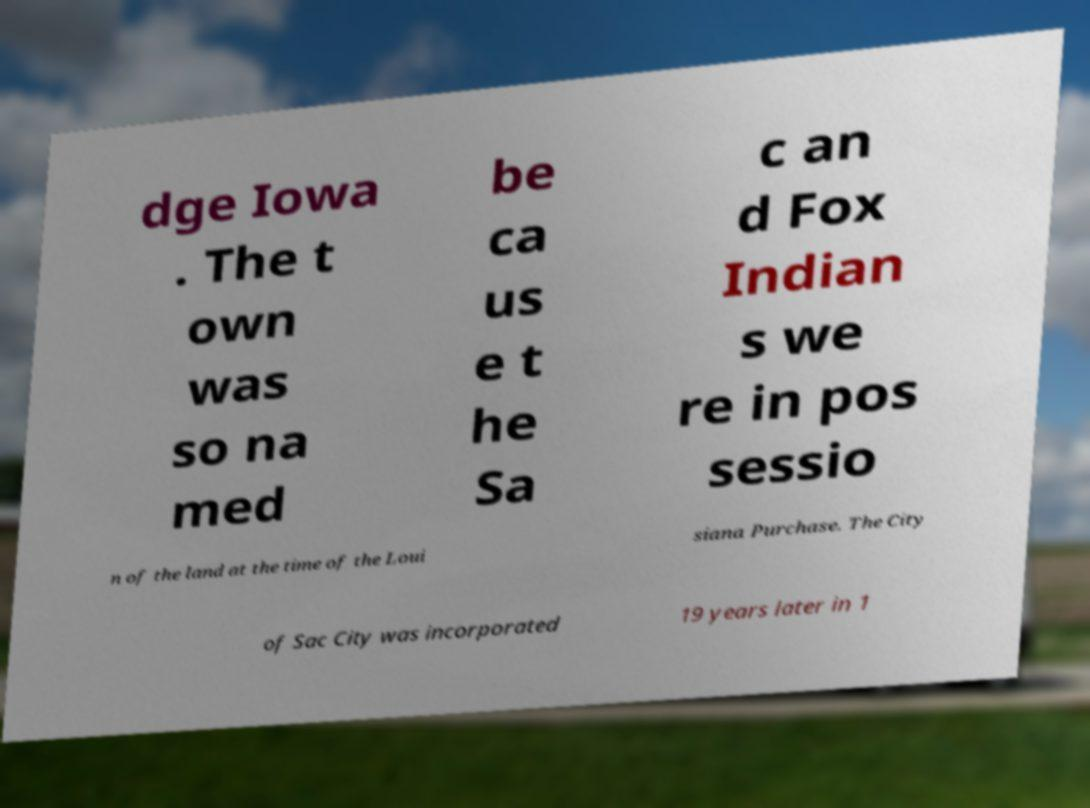Please read and relay the text visible in this image. What does it say? dge Iowa . The t own was so na med be ca us e t he Sa c an d Fox Indian s we re in pos sessio n of the land at the time of the Loui siana Purchase. The City of Sac City was incorporated 19 years later in 1 